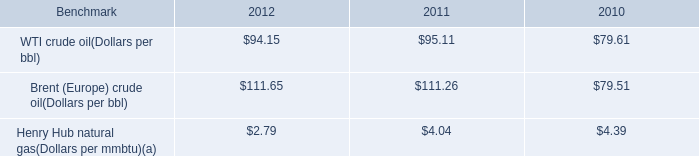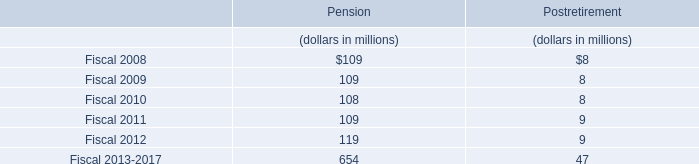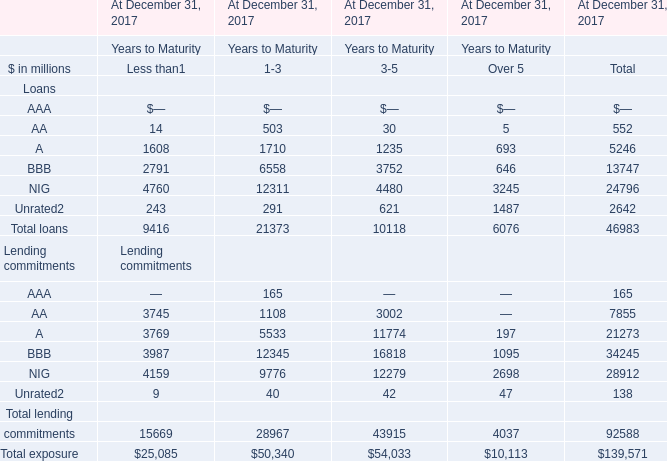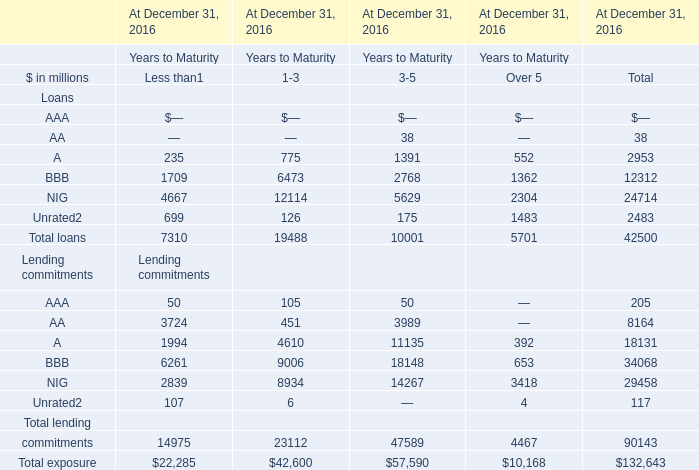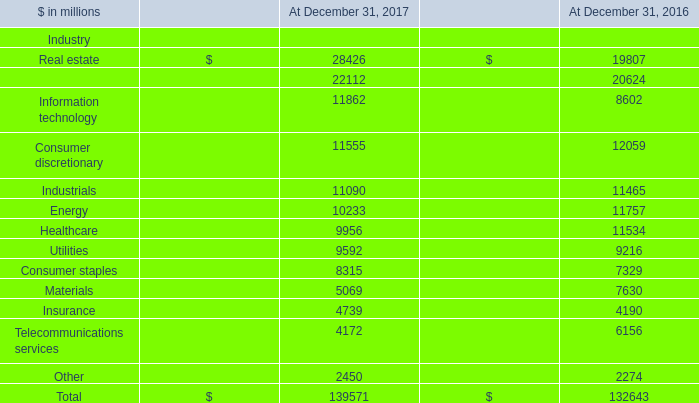what's the total amount of Energy of At December 31, 2017, BBB Loans of At December 31, 2016 Years to Maturity.1, and Telecommunications services of At December 31, 2017 ? 
Computations: ((10233.0 + 9006.0) + 4172.0)
Answer: 23411.0. 